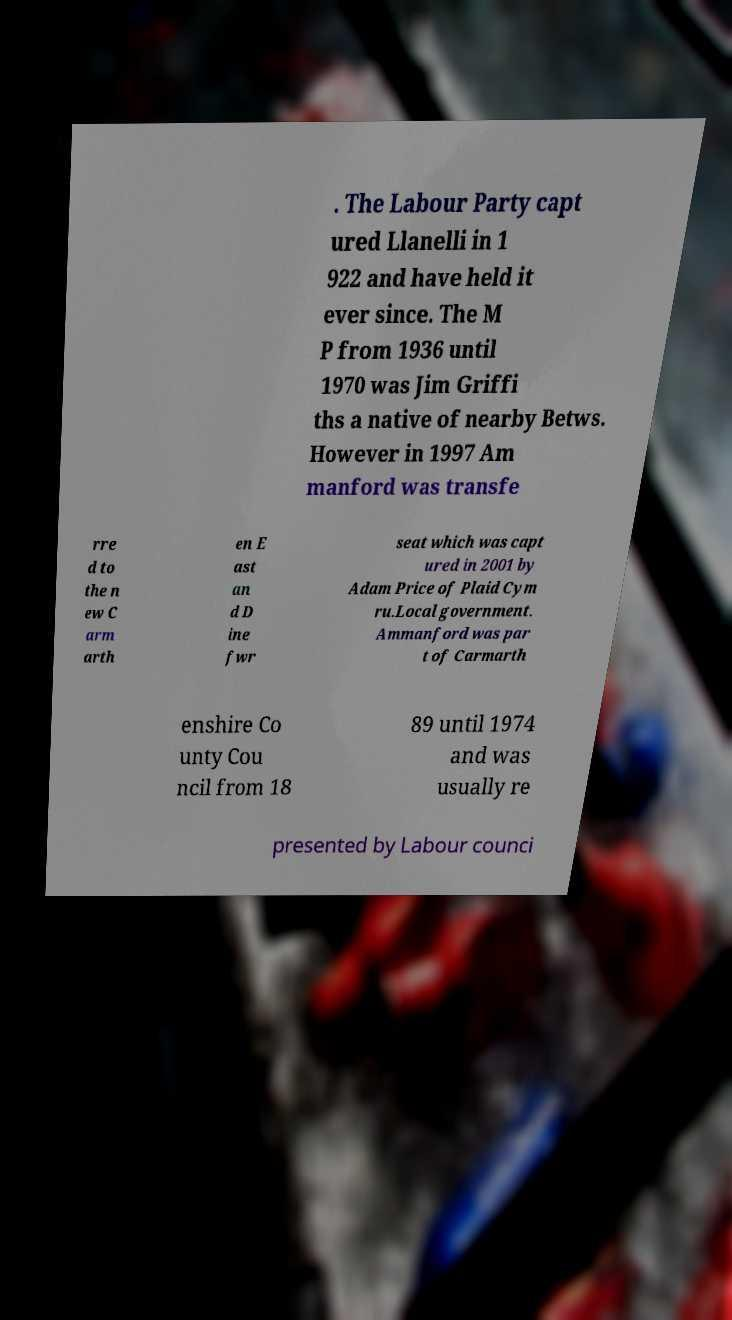There's text embedded in this image that I need extracted. Can you transcribe it verbatim? . The Labour Party capt ured Llanelli in 1 922 and have held it ever since. The M P from 1936 until 1970 was Jim Griffi ths a native of nearby Betws. However in 1997 Am manford was transfe rre d to the n ew C arm arth en E ast an d D ine fwr seat which was capt ured in 2001 by Adam Price of Plaid Cym ru.Local government. Ammanford was par t of Carmarth enshire Co unty Cou ncil from 18 89 until 1974 and was usually re presented by Labour counci 